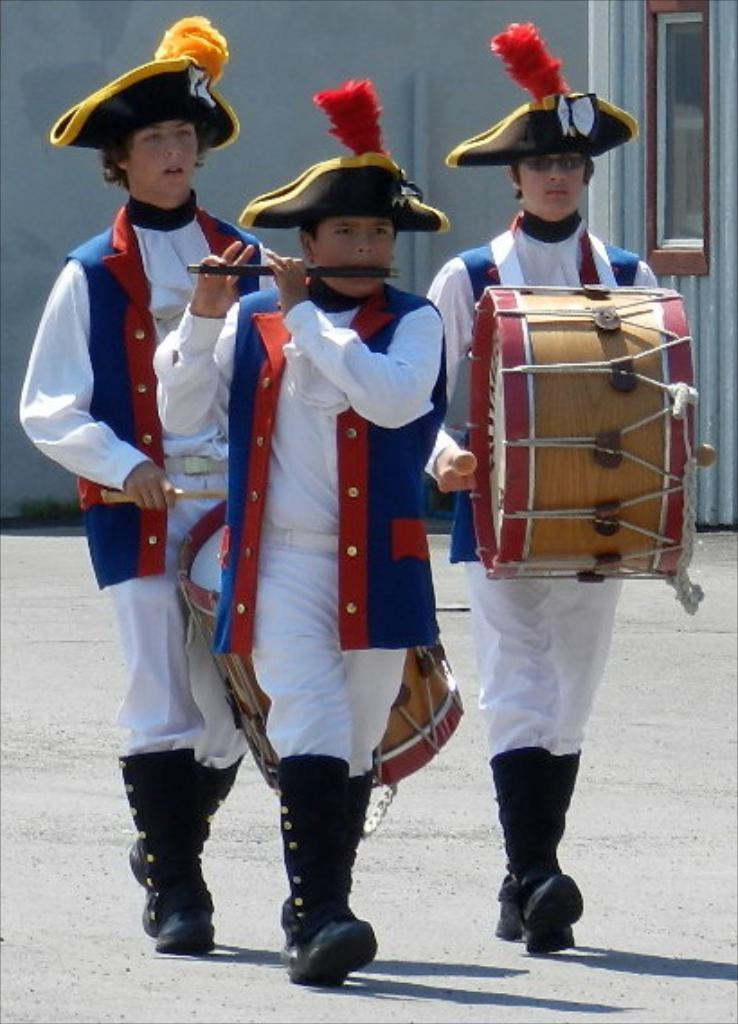How many men are in the image? There are three men in the image. What are two of the men doing? Two of the men are playing drums. What is the third man playing? The third man is playing a flute. What type of clothing are the men wearing on their heads? The men are wearing caps. What type of clothing are the men wearing on their upper bodies? The men are wearing jackets. What can be seen in the background of the image? There is a wall, a window, and pipes in the background of the image. How many drawers can be seen in the image? There are no drawers present in the image. Are the men swimming in the image? No, the men are not swimming in the image; they are playing musical instruments. 